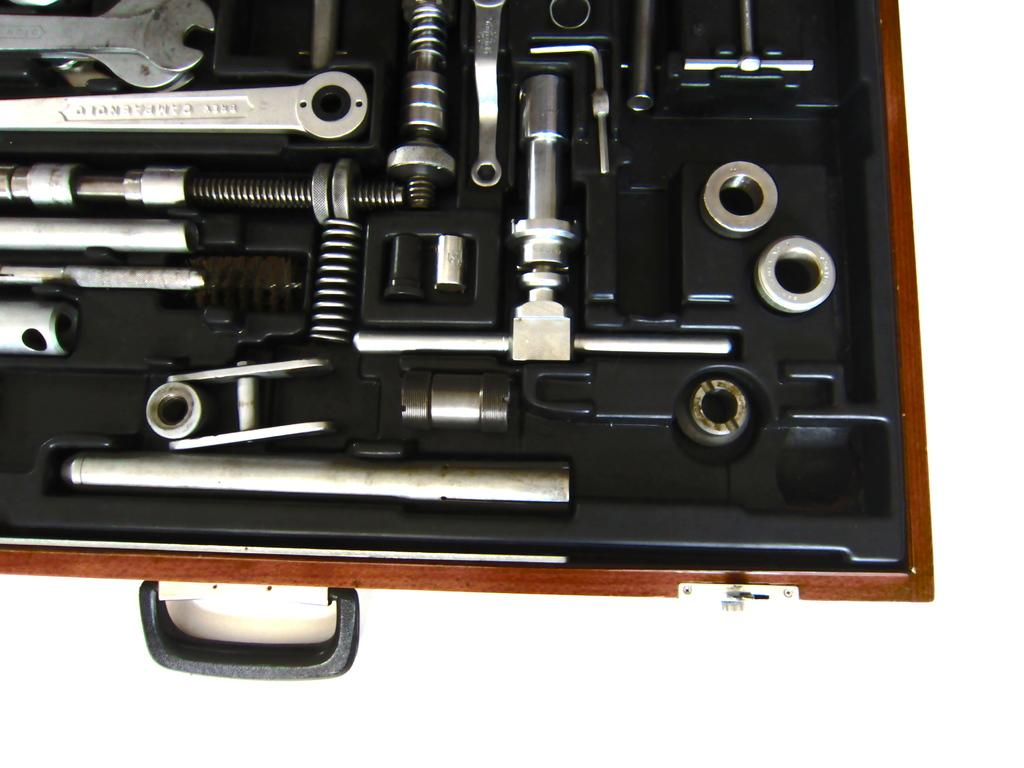What is the main object in the image? There is a toolbox in the image. What is inside the toolbox? The toolbox contains many tools. How many maids are present in the image? There are no maids present in the image; it only features a toolbox with tools. What type of girls can be seen playing with trains in the image? There are no girls or trains present in the image; it only features a toolbox with tools. 